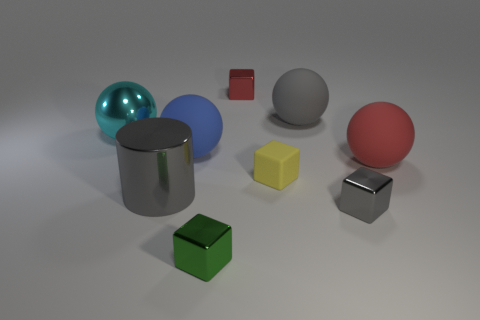Does the large rubber thing that is in front of the blue rubber thing have the same shape as the rubber thing that is in front of the large red object?
Your response must be concise. No. How many objects are either small green blocks or tiny brown spheres?
Your answer should be compact. 1. Is there any other thing that is made of the same material as the tiny red object?
Make the answer very short. Yes. Is there a large metal sphere?
Offer a very short reply. Yes. Is the large gray thing that is left of the green shiny cube made of the same material as the large red thing?
Keep it short and to the point. No. Is there another small green thing of the same shape as the small green metallic thing?
Your answer should be very brief. No. Are there an equal number of big cyan metal things right of the blue rubber thing and tiny green matte spheres?
Offer a terse response. Yes. What is the tiny object that is on the left side of the tiny shiny object that is behind the blue object made of?
Provide a succinct answer. Metal. The small red metallic object has what shape?
Offer a terse response. Cube. Are there the same number of gray metal things that are behind the small yellow rubber cube and matte balls on the left side of the gray metal block?
Your response must be concise. No. 